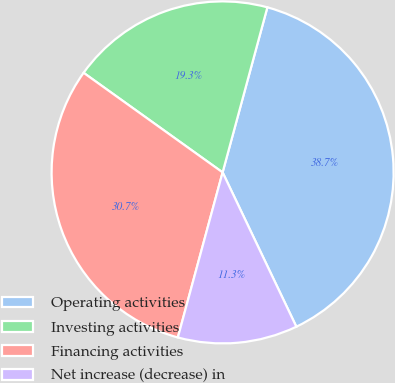Convert chart. <chart><loc_0><loc_0><loc_500><loc_500><pie_chart><fcel>Operating activities<fcel>Investing activities<fcel>Financing activities<fcel>Net increase (decrease) in<nl><fcel>38.69%<fcel>19.32%<fcel>30.68%<fcel>11.31%<nl></chart> 